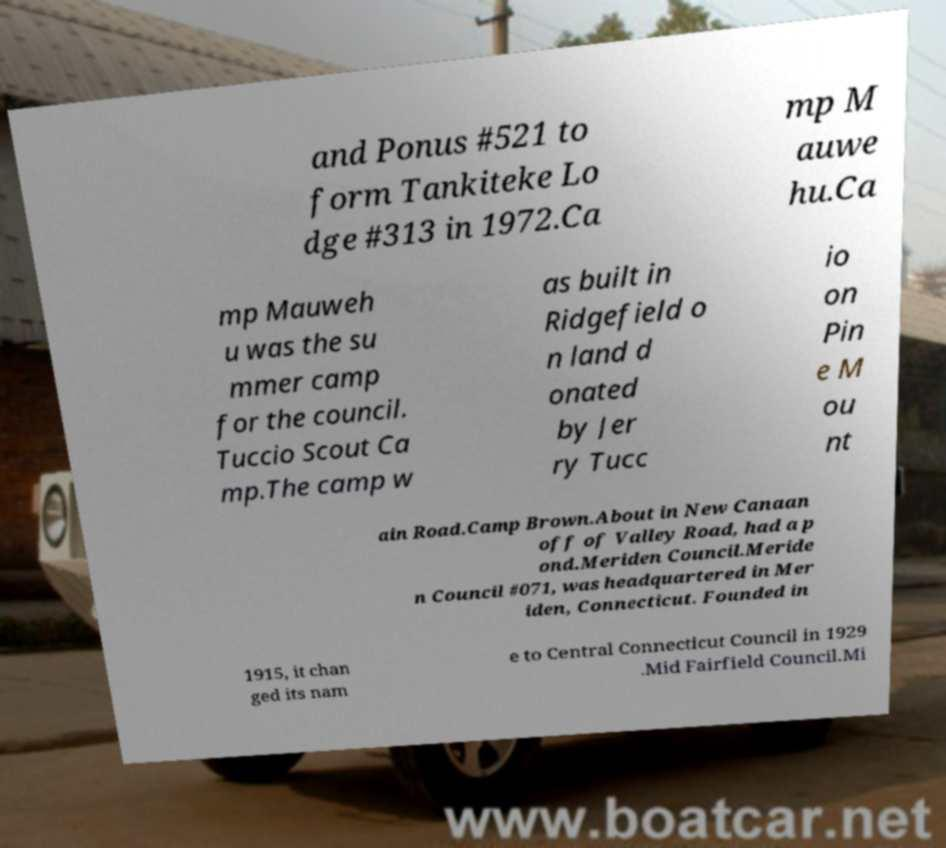Could you assist in decoding the text presented in this image and type it out clearly? and Ponus #521 to form Tankiteke Lo dge #313 in 1972.Ca mp M auwe hu.Ca mp Mauweh u was the su mmer camp for the council. Tuccio Scout Ca mp.The camp w as built in Ridgefield o n land d onated by Jer ry Tucc io on Pin e M ou nt ain Road.Camp Brown.About in New Canaan off of Valley Road, had a p ond.Meriden Council.Meride n Council #071, was headquartered in Mer iden, Connecticut. Founded in 1915, it chan ged its nam e to Central Connecticut Council in 1929 .Mid Fairfield Council.Mi 